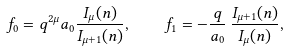Convert formula to latex. <formula><loc_0><loc_0><loc_500><loc_500>f _ { 0 } = q ^ { 2 \mu } a _ { 0 } \frac { I _ { \mu } ( n ) } { I _ { \mu + 1 } ( n ) } , \quad f _ { 1 } = - \frac { q } { a _ { 0 } } \, \frac { I _ { \mu + 1 } ( n ) } { I _ { \mu } ( n ) } ,</formula> 